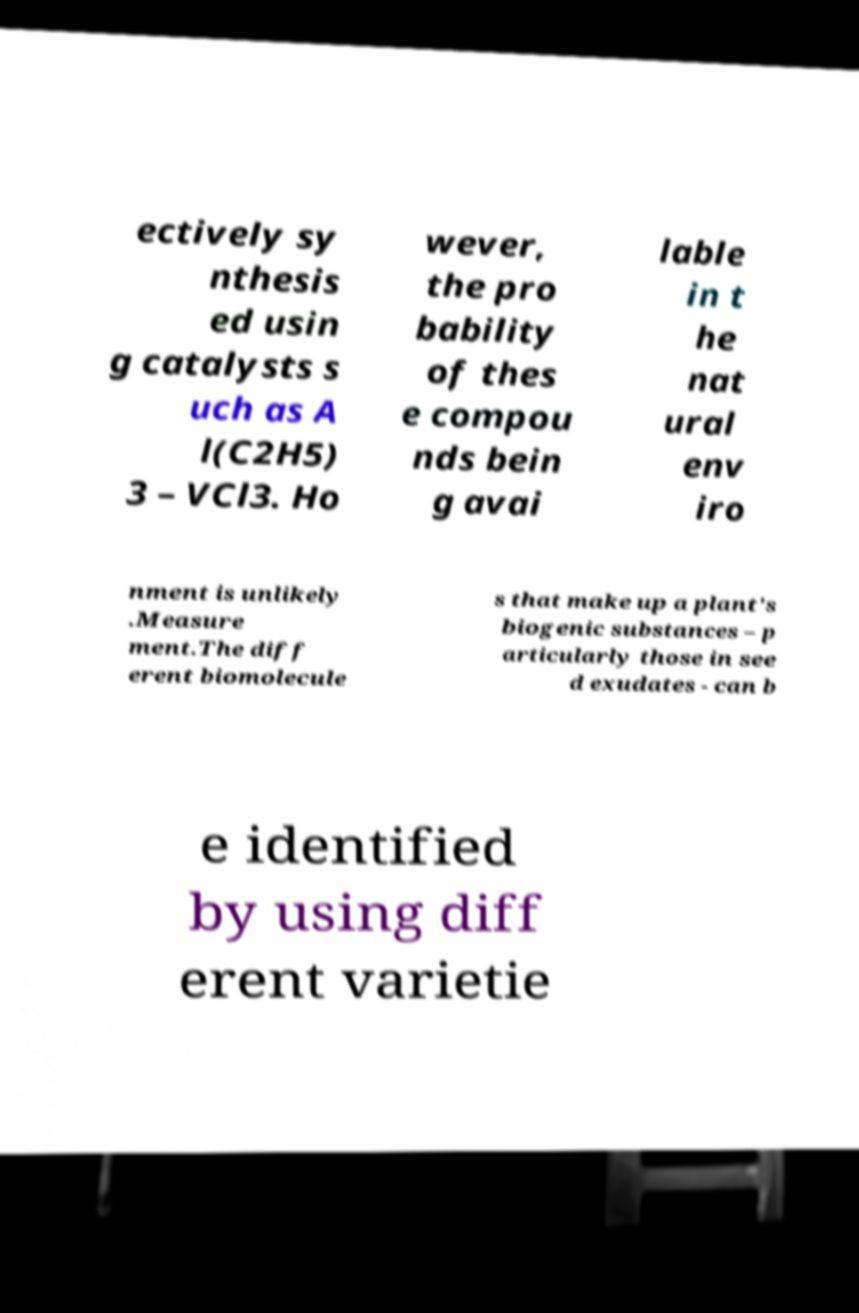Please read and relay the text visible in this image. What does it say? ectively sy nthesis ed usin g catalysts s uch as A l(C2H5) 3 – VCl3. Ho wever, the pro bability of thes e compou nds bein g avai lable in t he nat ural env iro nment is unlikely .Measure ment.The diff erent biomolecule s that make up a plant's biogenic substances – p articularly those in see d exudates - can b e identified by using diff erent varietie 